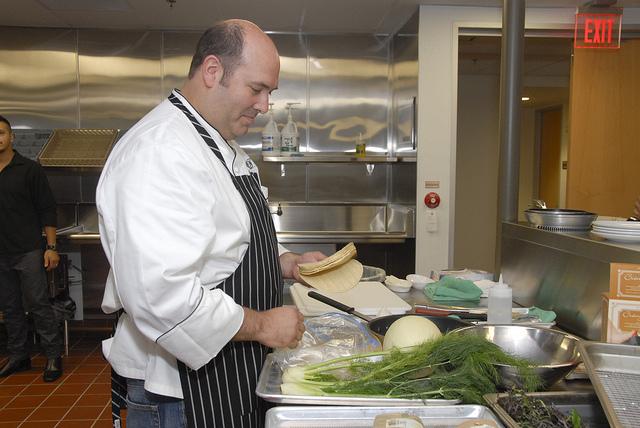Is this a personal kitchen?
Keep it brief. No. How many people are men?
Concise answer only. 2. What does the sign over the door say?
Answer briefly. Exit. Is the man wearing a watch?
Answer briefly. No. What is stacked by the man?
Short answer required. Tortillas. Are there any instances of cross-contamination in this picture?
Give a very brief answer. No. What green vegetables are being prepared?
Concise answer only. Onions. 